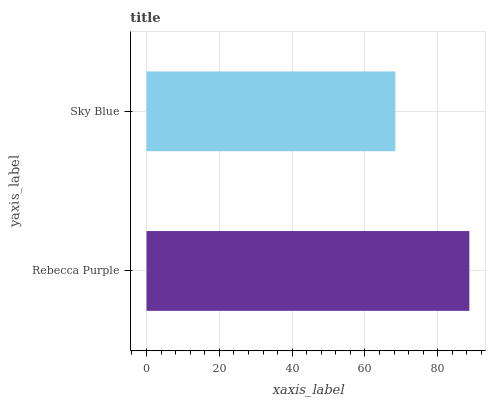Is Sky Blue the minimum?
Answer yes or no. Yes. Is Rebecca Purple the maximum?
Answer yes or no. Yes. Is Sky Blue the maximum?
Answer yes or no. No. Is Rebecca Purple greater than Sky Blue?
Answer yes or no. Yes. Is Sky Blue less than Rebecca Purple?
Answer yes or no. Yes. Is Sky Blue greater than Rebecca Purple?
Answer yes or no. No. Is Rebecca Purple less than Sky Blue?
Answer yes or no. No. Is Rebecca Purple the high median?
Answer yes or no. Yes. Is Sky Blue the low median?
Answer yes or no. Yes. Is Sky Blue the high median?
Answer yes or no. No. Is Rebecca Purple the low median?
Answer yes or no. No. 